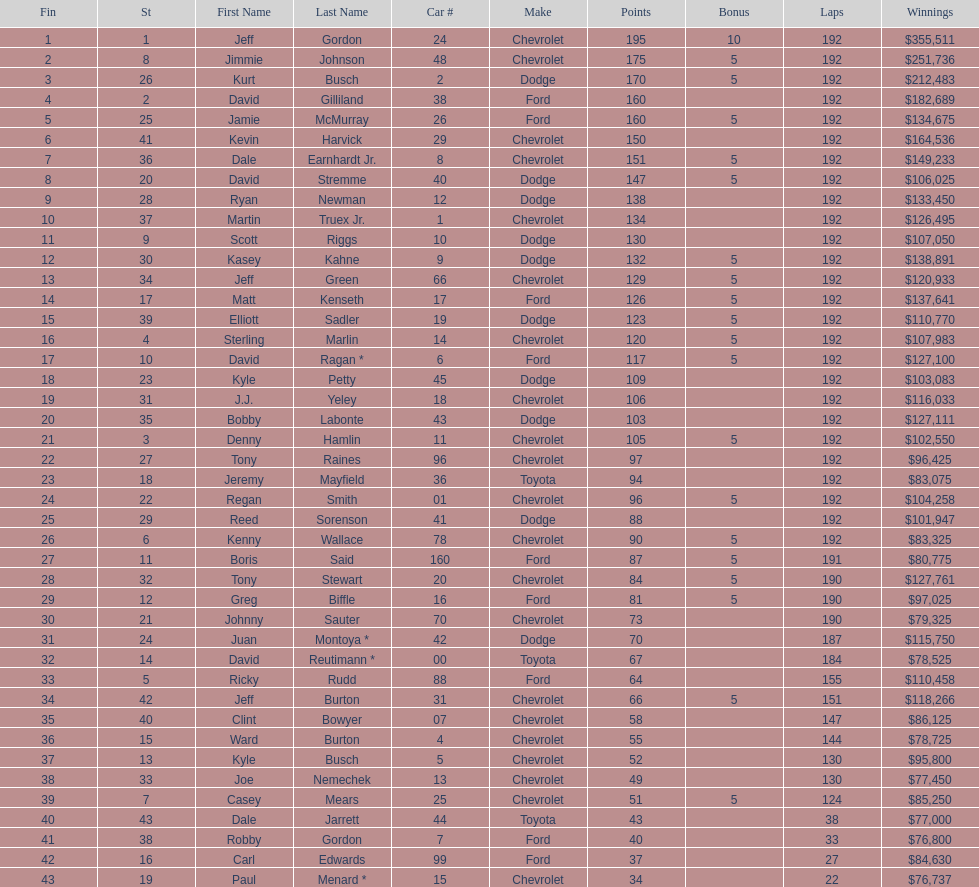Which make had the most consecutive finishes at the aarons 499? Chevrolet. 